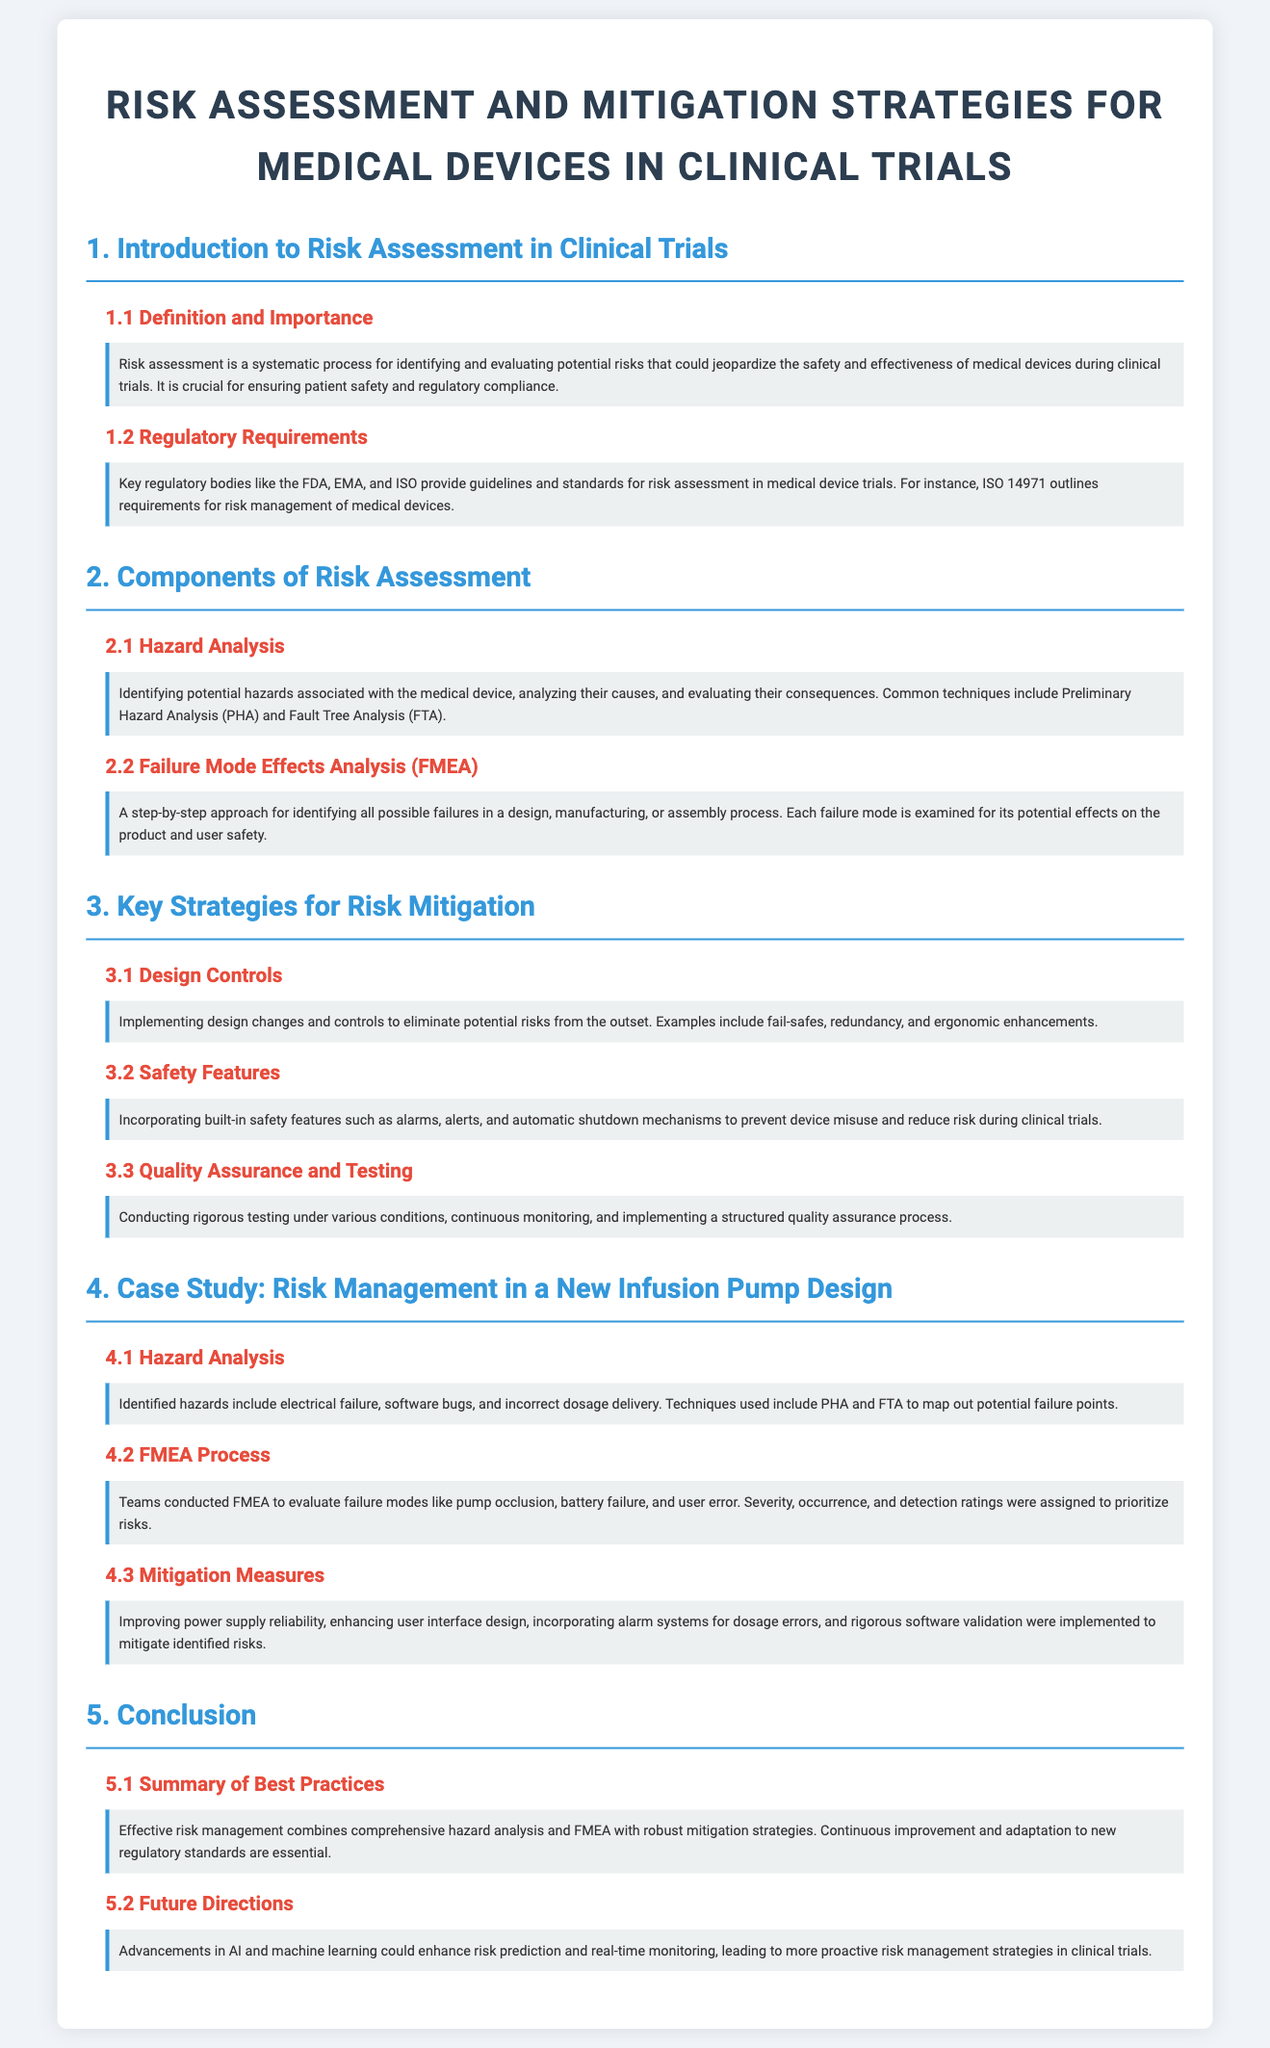what is the title of the document? The title of the document is found in the header and provides a clear indication of the content.
Answer: Risk Assessment and Mitigation Strategies for Medical Devices in Clinical Trials what does FMEA stand for? FMEA is mentioned in the section discussing analysis techniques, and it is an acronym that stands for Fault Mode Effects Analysis.
Answer: Failure Mode Effects Analysis which regulatory bodies provide guidelines for risk assessment? The section on regulatory requirements lists key organizations that oversee the guidelines, specifically mentioning three prominent ones.
Answer: FDA, EMA, and ISO what is one key component of risk assessment? The document outlines major components of risk assessment, from which a specific method can be highlighted.
Answer: Hazard Analysis which section discusses mitigation strategies? The document's structure categorizes information, making it clear which section focuses specifically on strategies for risk reduction.
Answer: Key Strategies for Risk Mitigation what is one method used in hazard analysis? The content highlights specific techniques used for identifying hazards, mentioning a common one specifically.
Answer: Preliminary Hazard Analysis how many subsections are in the case study section? By analyzing the structure of the case study section, we can determine the number of subsections it contains.
Answer: Three how does the document describe future directions? The conclusion section addresses potential advancements and the future of risk management, specifying the technologies involved.
Answer: AI and machine learning 